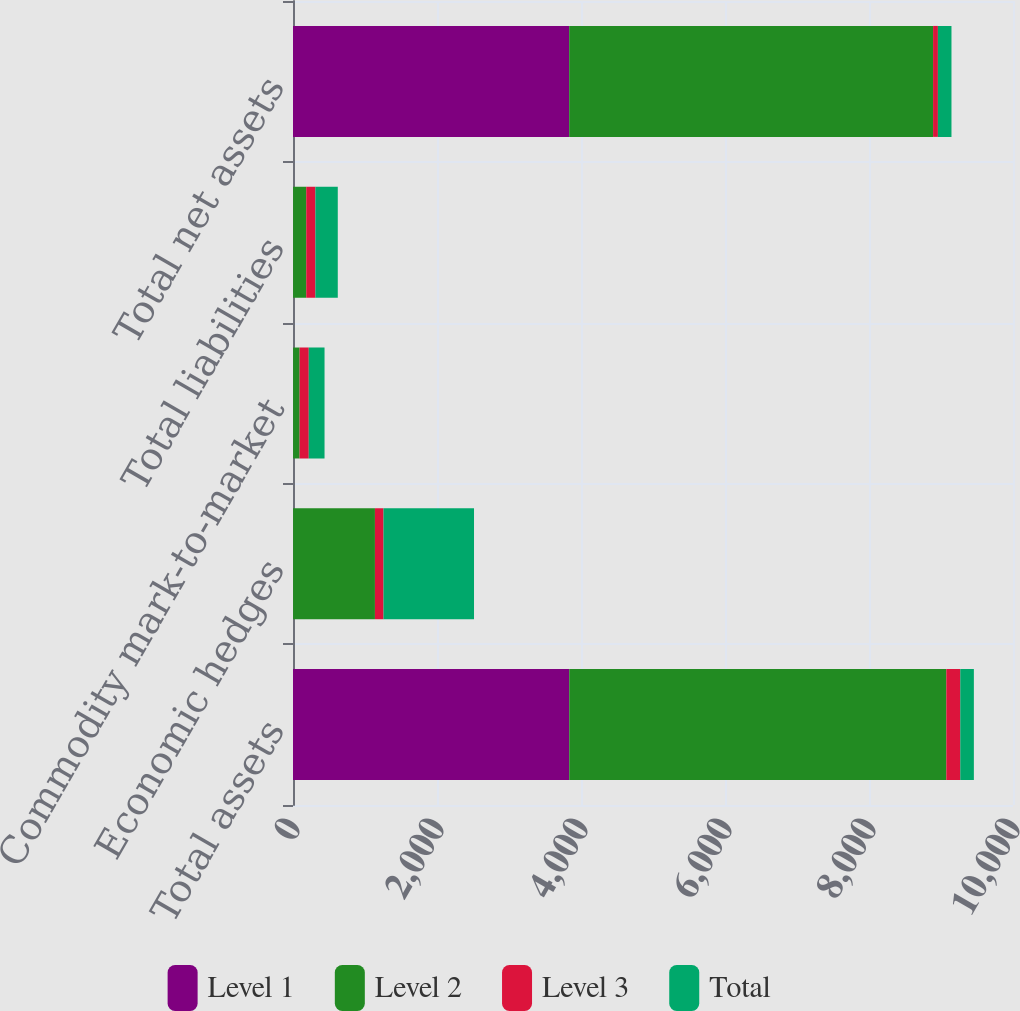Convert chart. <chart><loc_0><loc_0><loc_500><loc_500><stacked_bar_chart><ecel><fcel>Total assets<fcel>Economic hedges<fcel>Commodity mark-to-market<fcel>Total liabilities<fcel>Total net assets<nl><fcel>Level 1<fcel>3837<fcel>1<fcel>1<fcel>1<fcel>3836<nl><fcel>Level 2<fcel>5237<fcel>1137<fcel>91<fcel>183<fcel>5054<nl><fcel>Level 3<fcel>194<fcel>119<fcel>127<fcel>127<fcel>67<nl><fcel>Total<fcel>188.5<fcel>1257<fcel>219<fcel>311<fcel>188.5<nl></chart> 